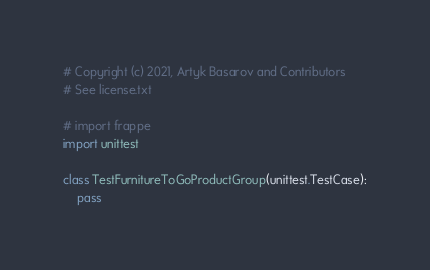Convert code to text. <code><loc_0><loc_0><loc_500><loc_500><_Python_># Copyright (c) 2021, Artyk Basarov and Contributors
# See license.txt

# import frappe
import unittest

class TestFurnitureToGoProductGroup(unittest.TestCase):
	pass
</code> 